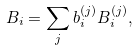<formula> <loc_0><loc_0><loc_500><loc_500>B _ { i } = \sum _ { j } b _ { i } ^ { ( j ) } B _ { i } ^ { ( j ) } ,</formula> 